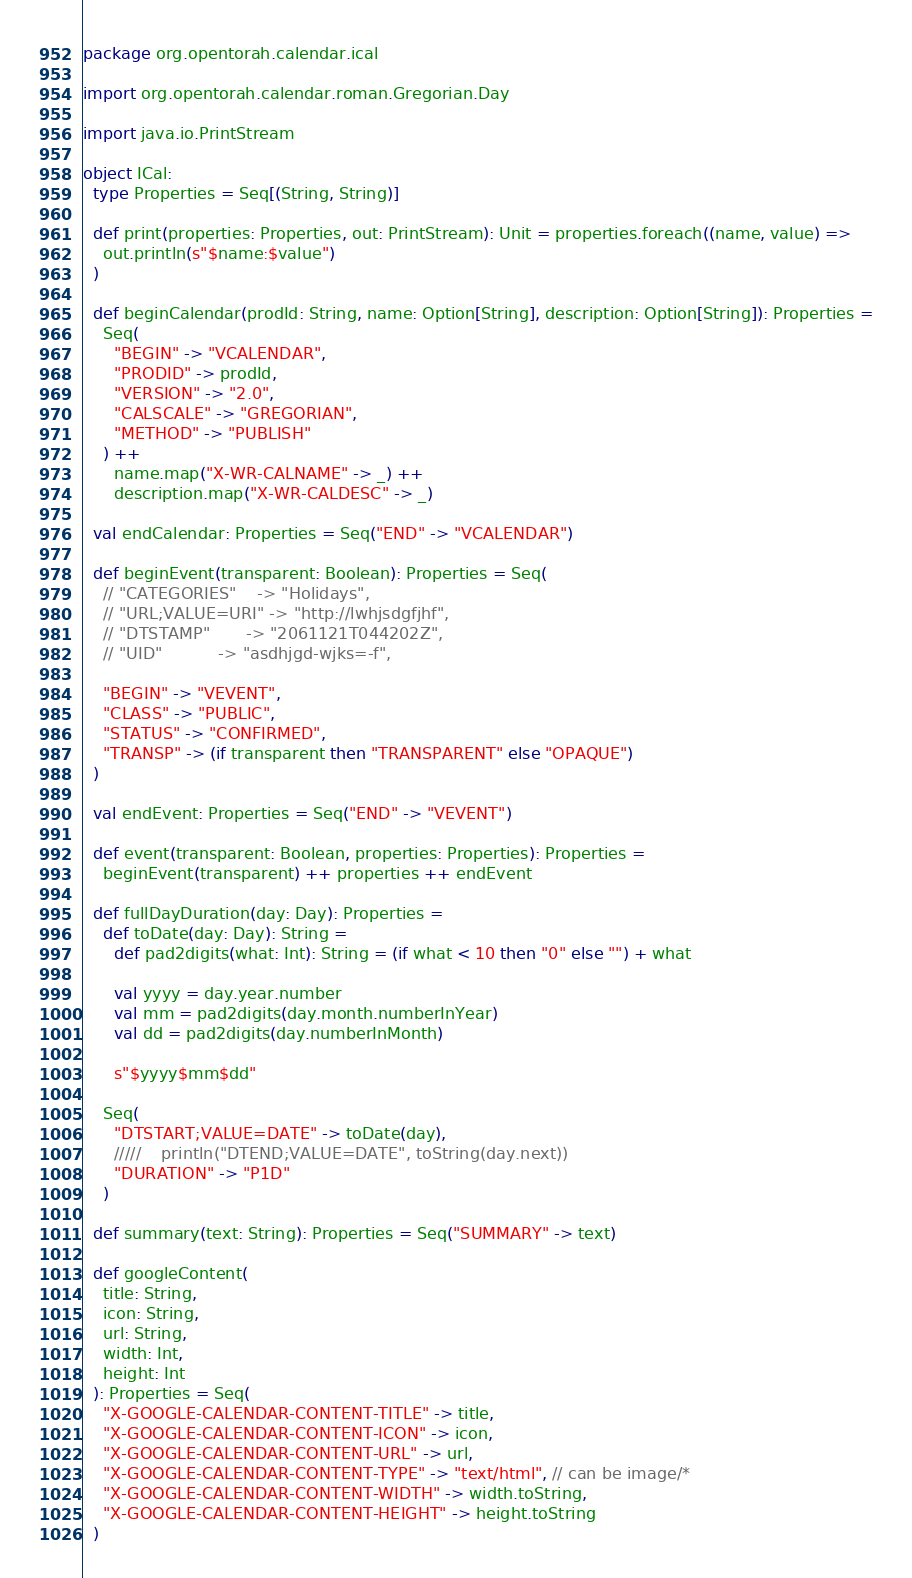Convert code to text. <code><loc_0><loc_0><loc_500><loc_500><_Scala_>package org.opentorah.calendar.ical

import org.opentorah.calendar.roman.Gregorian.Day

import java.io.PrintStream

object ICal:
  type Properties = Seq[(String, String)]

  def print(properties: Properties, out: PrintStream): Unit = properties.foreach((name, value) =>
    out.println(s"$name:$value")
  )

  def beginCalendar(prodId: String, name: Option[String], description: Option[String]): Properties =
    Seq(
      "BEGIN" -> "VCALENDAR",
      "PRODID" -> prodId,
      "VERSION" -> "2.0",
      "CALSCALE" -> "GREGORIAN",
      "METHOD" -> "PUBLISH"
    ) ++
      name.map("X-WR-CALNAME" -> _) ++
      description.map("X-WR-CALDESC" -> _)

  val endCalendar: Properties = Seq("END" -> "VCALENDAR")

  def beginEvent(transparent: Boolean): Properties = Seq(
    // "CATEGORIES"    -> "Holidays",
    // "URL;VALUE=URI" -> "http://lwhjsdgfjhf",
    // "DTSTAMP"       -> "2061121T044202Z",
    // "UID"           -> "asdhjgd-wjks=-f",

    "BEGIN" -> "VEVENT",
    "CLASS" -> "PUBLIC",
    "STATUS" -> "CONFIRMED",
    "TRANSP" -> (if transparent then "TRANSPARENT" else "OPAQUE")
  )

  val endEvent: Properties = Seq("END" -> "VEVENT")

  def event(transparent: Boolean, properties: Properties): Properties =
    beginEvent(transparent) ++ properties ++ endEvent

  def fullDayDuration(day: Day): Properties =
    def toDate(day: Day): String =
      def pad2digits(what: Int): String = (if what < 10 then "0" else "") + what

      val yyyy = day.year.number
      val mm = pad2digits(day.month.numberInYear)
      val dd = pad2digits(day.numberInMonth)

      s"$yyyy$mm$dd"

    Seq(
      "DTSTART;VALUE=DATE" -> toDate(day),
      /////    println("DTEND;VALUE=DATE", toString(day.next))
      "DURATION" -> "P1D"
    )

  def summary(text: String): Properties = Seq("SUMMARY" -> text)

  def googleContent(
    title: String,
    icon: String,
    url: String,
    width: Int,
    height: Int
  ): Properties = Seq(
    "X-GOOGLE-CALENDAR-CONTENT-TITLE" -> title,
    "X-GOOGLE-CALENDAR-CONTENT-ICON" -> icon,
    "X-GOOGLE-CALENDAR-CONTENT-URL" -> url,
    "X-GOOGLE-CALENDAR-CONTENT-TYPE" -> "text/html", // can be image/*
    "X-GOOGLE-CALENDAR-CONTENT-WIDTH" -> width.toString,
    "X-GOOGLE-CALENDAR-CONTENT-HEIGHT" -> height.toString
  )
</code> 